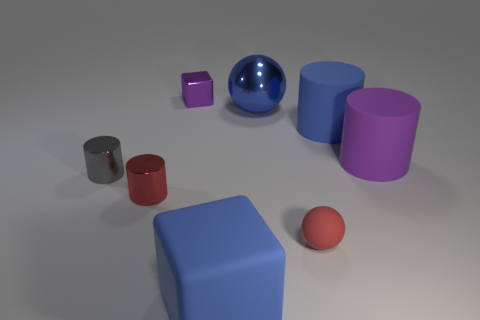Add 1 green shiny cylinders. How many objects exist? 9 Subtract all large blue matte cylinders. How many cylinders are left? 3 Subtract 1 cylinders. How many cylinders are left? 3 Subtract all blue blocks. How many blocks are left? 1 Subtract 1 blue blocks. How many objects are left? 7 Subtract all yellow cylinders. Subtract all cyan blocks. How many cylinders are left? 4 Subtract all blue cubes. How many red spheres are left? 1 Subtract all large rubber objects. Subtract all tiny gray metallic things. How many objects are left? 4 Add 3 purple cylinders. How many purple cylinders are left? 4 Add 7 purple metallic cubes. How many purple metallic cubes exist? 8 